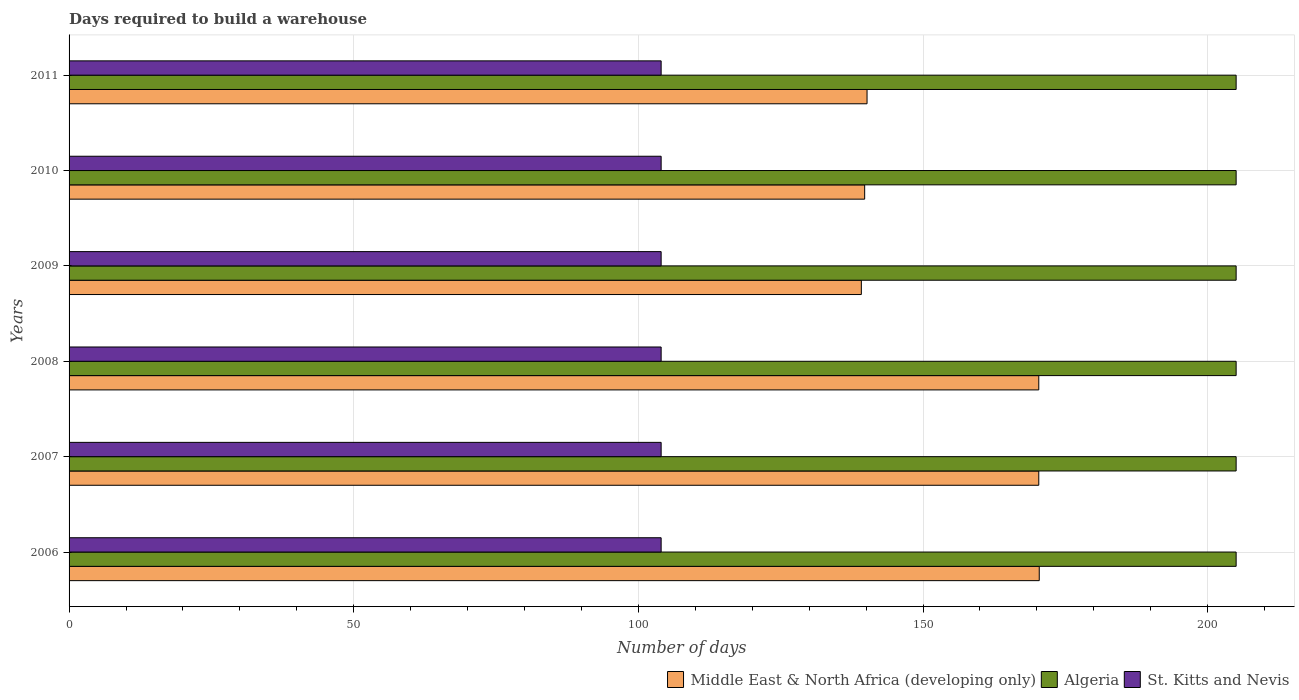How many different coloured bars are there?
Provide a succinct answer. 3. Are the number of bars per tick equal to the number of legend labels?
Give a very brief answer. Yes. Are the number of bars on each tick of the Y-axis equal?
Ensure brevity in your answer.  Yes. How many bars are there on the 5th tick from the bottom?
Your answer should be very brief. 3. What is the days required to build a warehouse in in St. Kitts and Nevis in 2008?
Keep it short and to the point. 104. Across all years, what is the maximum days required to build a warehouse in in Algeria?
Provide a short and direct response. 205. Across all years, what is the minimum days required to build a warehouse in in Middle East & North Africa (developing only)?
Ensure brevity in your answer.  139.17. In which year was the days required to build a warehouse in in St. Kitts and Nevis maximum?
Your answer should be very brief. 2006. In which year was the days required to build a warehouse in in Middle East & North Africa (developing only) minimum?
Provide a short and direct response. 2009. What is the total days required to build a warehouse in in St. Kitts and Nevis in the graph?
Provide a succinct answer. 624. What is the difference between the days required to build a warehouse in in St. Kitts and Nevis in 2006 and that in 2009?
Make the answer very short. 0. What is the difference between the days required to build a warehouse in in Algeria in 2010 and the days required to build a warehouse in in Middle East & North Africa (developing only) in 2011?
Your answer should be compact. 64.83. What is the average days required to build a warehouse in in Middle East & North Africa (developing only) per year?
Give a very brief answer. 155.03. In the year 2011, what is the difference between the days required to build a warehouse in in St. Kitts and Nevis and days required to build a warehouse in in Algeria?
Your answer should be very brief. -101. What is the ratio of the days required to build a warehouse in in Middle East & North Africa (developing only) in 2010 to that in 2011?
Your answer should be very brief. 1. What is the difference between the highest and the second highest days required to build a warehouse in in Middle East & North Africa (developing only)?
Keep it short and to the point. 0.08. What is the difference between the highest and the lowest days required to build a warehouse in in Algeria?
Keep it short and to the point. 0. In how many years, is the days required to build a warehouse in in Middle East & North Africa (developing only) greater than the average days required to build a warehouse in in Middle East & North Africa (developing only) taken over all years?
Your answer should be compact. 3. Is the sum of the days required to build a warehouse in in St. Kitts and Nevis in 2006 and 2007 greater than the maximum days required to build a warehouse in in Algeria across all years?
Your answer should be compact. Yes. What does the 1st bar from the top in 2006 represents?
Make the answer very short. St. Kitts and Nevis. What does the 1st bar from the bottom in 2007 represents?
Provide a short and direct response. Middle East & North Africa (developing only). Are all the bars in the graph horizontal?
Offer a terse response. Yes. What is the difference between two consecutive major ticks on the X-axis?
Provide a short and direct response. 50. Are the values on the major ticks of X-axis written in scientific E-notation?
Your answer should be compact. No. Does the graph contain grids?
Provide a succinct answer. Yes. How are the legend labels stacked?
Ensure brevity in your answer.  Horizontal. What is the title of the graph?
Your answer should be compact. Days required to build a warehouse. What is the label or title of the X-axis?
Your answer should be compact. Number of days. What is the label or title of the Y-axis?
Provide a succinct answer. Years. What is the Number of days of Middle East & North Africa (developing only) in 2006?
Offer a very short reply. 170.42. What is the Number of days of Algeria in 2006?
Provide a succinct answer. 205. What is the Number of days in St. Kitts and Nevis in 2006?
Ensure brevity in your answer.  104. What is the Number of days of Middle East & North Africa (developing only) in 2007?
Ensure brevity in your answer.  170.33. What is the Number of days of Algeria in 2007?
Make the answer very short. 205. What is the Number of days of St. Kitts and Nevis in 2007?
Your answer should be compact. 104. What is the Number of days of Middle East & North Africa (developing only) in 2008?
Ensure brevity in your answer.  170.33. What is the Number of days in Algeria in 2008?
Your response must be concise. 205. What is the Number of days in St. Kitts and Nevis in 2008?
Provide a succinct answer. 104. What is the Number of days in Middle East & North Africa (developing only) in 2009?
Offer a very short reply. 139.17. What is the Number of days in Algeria in 2009?
Keep it short and to the point. 205. What is the Number of days in St. Kitts and Nevis in 2009?
Ensure brevity in your answer.  104. What is the Number of days of Middle East & North Africa (developing only) in 2010?
Keep it short and to the point. 139.75. What is the Number of days in Algeria in 2010?
Offer a very short reply. 205. What is the Number of days of St. Kitts and Nevis in 2010?
Ensure brevity in your answer.  104. What is the Number of days in Middle East & North Africa (developing only) in 2011?
Offer a terse response. 140.17. What is the Number of days in Algeria in 2011?
Give a very brief answer. 205. What is the Number of days of St. Kitts and Nevis in 2011?
Give a very brief answer. 104. Across all years, what is the maximum Number of days in Middle East & North Africa (developing only)?
Offer a very short reply. 170.42. Across all years, what is the maximum Number of days in Algeria?
Make the answer very short. 205. Across all years, what is the maximum Number of days of St. Kitts and Nevis?
Keep it short and to the point. 104. Across all years, what is the minimum Number of days of Middle East & North Africa (developing only)?
Keep it short and to the point. 139.17. Across all years, what is the minimum Number of days of Algeria?
Offer a very short reply. 205. Across all years, what is the minimum Number of days of St. Kitts and Nevis?
Your response must be concise. 104. What is the total Number of days of Middle East & North Africa (developing only) in the graph?
Your response must be concise. 930.17. What is the total Number of days in Algeria in the graph?
Give a very brief answer. 1230. What is the total Number of days in St. Kitts and Nevis in the graph?
Provide a short and direct response. 624. What is the difference between the Number of days in Middle East & North Africa (developing only) in 2006 and that in 2007?
Keep it short and to the point. 0.08. What is the difference between the Number of days of Middle East & North Africa (developing only) in 2006 and that in 2008?
Your answer should be very brief. 0.08. What is the difference between the Number of days in Algeria in 2006 and that in 2008?
Ensure brevity in your answer.  0. What is the difference between the Number of days in Middle East & North Africa (developing only) in 2006 and that in 2009?
Provide a succinct answer. 31.25. What is the difference between the Number of days in Algeria in 2006 and that in 2009?
Offer a very short reply. 0. What is the difference between the Number of days of Middle East & North Africa (developing only) in 2006 and that in 2010?
Keep it short and to the point. 30.67. What is the difference between the Number of days of Middle East & North Africa (developing only) in 2006 and that in 2011?
Provide a succinct answer. 30.25. What is the difference between the Number of days in Algeria in 2006 and that in 2011?
Provide a short and direct response. 0. What is the difference between the Number of days in Middle East & North Africa (developing only) in 2007 and that in 2008?
Give a very brief answer. 0. What is the difference between the Number of days of Algeria in 2007 and that in 2008?
Offer a terse response. 0. What is the difference between the Number of days in Middle East & North Africa (developing only) in 2007 and that in 2009?
Offer a terse response. 31.17. What is the difference between the Number of days of Algeria in 2007 and that in 2009?
Your answer should be compact. 0. What is the difference between the Number of days of St. Kitts and Nevis in 2007 and that in 2009?
Offer a very short reply. 0. What is the difference between the Number of days in Middle East & North Africa (developing only) in 2007 and that in 2010?
Ensure brevity in your answer.  30.58. What is the difference between the Number of days of Algeria in 2007 and that in 2010?
Give a very brief answer. 0. What is the difference between the Number of days of St. Kitts and Nevis in 2007 and that in 2010?
Provide a succinct answer. 0. What is the difference between the Number of days in Middle East & North Africa (developing only) in 2007 and that in 2011?
Your response must be concise. 30.17. What is the difference between the Number of days in Algeria in 2007 and that in 2011?
Ensure brevity in your answer.  0. What is the difference between the Number of days of St. Kitts and Nevis in 2007 and that in 2011?
Keep it short and to the point. 0. What is the difference between the Number of days in Middle East & North Africa (developing only) in 2008 and that in 2009?
Your answer should be very brief. 31.17. What is the difference between the Number of days in Middle East & North Africa (developing only) in 2008 and that in 2010?
Offer a very short reply. 30.58. What is the difference between the Number of days in St. Kitts and Nevis in 2008 and that in 2010?
Offer a terse response. 0. What is the difference between the Number of days in Middle East & North Africa (developing only) in 2008 and that in 2011?
Make the answer very short. 30.17. What is the difference between the Number of days of Middle East & North Africa (developing only) in 2009 and that in 2010?
Your answer should be very brief. -0.58. What is the difference between the Number of days in Middle East & North Africa (developing only) in 2009 and that in 2011?
Provide a short and direct response. -1. What is the difference between the Number of days of St. Kitts and Nevis in 2009 and that in 2011?
Ensure brevity in your answer.  0. What is the difference between the Number of days of Middle East & North Africa (developing only) in 2010 and that in 2011?
Your response must be concise. -0.42. What is the difference between the Number of days of Algeria in 2010 and that in 2011?
Offer a very short reply. 0. What is the difference between the Number of days in Middle East & North Africa (developing only) in 2006 and the Number of days in Algeria in 2007?
Give a very brief answer. -34.58. What is the difference between the Number of days in Middle East & North Africa (developing only) in 2006 and the Number of days in St. Kitts and Nevis in 2007?
Offer a very short reply. 66.42. What is the difference between the Number of days of Algeria in 2006 and the Number of days of St. Kitts and Nevis in 2007?
Provide a succinct answer. 101. What is the difference between the Number of days of Middle East & North Africa (developing only) in 2006 and the Number of days of Algeria in 2008?
Your answer should be compact. -34.58. What is the difference between the Number of days in Middle East & North Africa (developing only) in 2006 and the Number of days in St. Kitts and Nevis in 2008?
Offer a terse response. 66.42. What is the difference between the Number of days in Algeria in 2006 and the Number of days in St. Kitts and Nevis in 2008?
Ensure brevity in your answer.  101. What is the difference between the Number of days of Middle East & North Africa (developing only) in 2006 and the Number of days of Algeria in 2009?
Offer a terse response. -34.58. What is the difference between the Number of days of Middle East & North Africa (developing only) in 2006 and the Number of days of St. Kitts and Nevis in 2009?
Provide a short and direct response. 66.42. What is the difference between the Number of days of Algeria in 2006 and the Number of days of St. Kitts and Nevis in 2009?
Give a very brief answer. 101. What is the difference between the Number of days in Middle East & North Africa (developing only) in 2006 and the Number of days in Algeria in 2010?
Keep it short and to the point. -34.58. What is the difference between the Number of days of Middle East & North Africa (developing only) in 2006 and the Number of days of St. Kitts and Nevis in 2010?
Offer a terse response. 66.42. What is the difference between the Number of days in Algeria in 2006 and the Number of days in St. Kitts and Nevis in 2010?
Your answer should be very brief. 101. What is the difference between the Number of days of Middle East & North Africa (developing only) in 2006 and the Number of days of Algeria in 2011?
Make the answer very short. -34.58. What is the difference between the Number of days of Middle East & North Africa (developing only) in 2006 and the Number of days of St. Kitts and Nevis in 2011?
Your answer should be compact. 66.42. What is the difference between the Number of days in Algeria in 2006 and the Number of days in St. Kitts and Nevis in 2011?
Provide a short and direct response. 101. What is the difference between the Number of days in Middle East & North Africa (developing only) in 2007 and the Number of days in Algeria in 2008?
Your response must be concise. -34.67. What is the difference between the Number of days of Middle East & North Africa (developing only) in 2007 and the Number of days of St. Kitts and Nevis in 2008?
Keep it short and to the point. 66.33. What is the difference between the Number of days of Algeria in 2007 and the Number of days of St. Kitts and Nevis in 2008?
Your response must be concise. 101. What is the difference between the Number of days in Middle East & North Africa (developing only) in 2007 and the Number of days in Algeria in 2009?
Your response must be concise. -34.67. What is the difference between the Number of days of Middle East & North Africa (developing only) in 2007 and the Number of days of St. Kitts and Nevis in 2009?
Your answer should be very brief. 66.33. What is the difference between the Number of days of Algeria in 2007 and the Number of days of St. Kitts and Nevis in 2009?
Provide a succinct answer. 101. What is the difference between the Number of days in Middle East & North Africa (developing only) in 2007 and the Number of days in Algeria in 2010?
Provide a succinct answer. -34.67. What is the difference between the Number of days in Middle East & North Africa (developing only) in 2007 and the Number of days in St. Kitts and Nevis in 2010?
Offer a very short reply. 66.33. What is the difference between the Number of days of Algeria in 2007 and the Number of days of St. Kitts and Nevis in 2010?
Your response must be concise. 101. What is the difference between the Number of days of Middle East & North Africa (developing only) in 2007 and the Number of days of Algeria in 2011?
Offer a terse response. -34.67. What is the difference between the Number of days in Middle East & North Africa (developing only) in 2007 and the Number of days in St. Kitts and Nevis in 2011?
Ensure brevity in your answer.  66.33. What is the difference between the Number of days in Algeria in 2007 and the Number of days in St. Kitts and Nevis in 2011?
Ensure brevity in your answer.  101. What is the difference between the Number of days in Middle East & North Africa (developing only) in 2008 and the Number of days in Algeria in 2009?
Offer a terse response. -34.67. What is the difference between the Number of days of Middle East & North Africa (developing only) in 2008 and the Number of days of St. Kitts and Nevis in 2009?
Provide a succinct answer. 66.33. What is the difference between the Number of days in Algeria in 2008 and the Number of days in St. Kitts and Nevis in 2009?
Offer a terse response. 101. What is the difference between the Number of days in Middle East & North Africa (developing only) in 2008 and the Number of days in Algeria in 2010?
Provide a short and direct response. -34.67. What is the difference between the Number of days of Middle East & North Africa (developing only) in 2008 and the Number of days of St. Kitts and Nevis in 2010?
Offer a terse response. 66.33. What is the difference between the Number of days in Algeria in 2008 and the Number of days in St. Kitts and Nevis in 2010?
Offer a terse response. 101. What is the difference between the Number of days of Middle East & North Africa (developing only) in 2008 and the Number of days of Algeria in 2011?
Provide a short and direct response. -34.67. What is the difference between the Number of days of Middle East & North Africa (developing only) in 2008 and the Number of days of St. Kitts and Nevis in 2011?
Make the answer very short. 66.33. What is the difference between the Number of days of Algeria in 2008 and the Number of days of St. Kitts and Nevis in 2011?
Your response must be concise. 101. What is the difference between the Number of days of Middle East & North Africa (developing only) in 2009 and the Number of days of Algeria in 2010?
Your response must be concise. -65.83. What is the difference between the Number of days of Middle East & North Africa (developing only) in 2009 and the Number of days of St. Kitts and Nevis in 2010?
Offer a very short reply. 35.17. What is the difference between the Number of days in Algeria in 2009 and the Number of days in St. Kitts and Nevis in 2010?
Offer a terse response. 101. What is the difference between the Number of days in Middle East & North Africa (developing only) in 2009 and the Number of days in Algeria in 2011?
Your answer should be compact. -65.83. What is the difference between the Number of days in Middle East & North Africa (developing only) in 2009 and the Number of days in St. Kitts and Nevis in 2011?
Your response must be concise. 35.17. What is the difference between the Number of days in Algeria in 2009 and the Number of days in St. Kitts and Nevis in 2011?
Offer a very short reply. 101. What is the difference between the Number of days in Middle East & North Africa (developing only) in 2010 and the Number of days in Algeria in 2011?
Provide a succinct answer. -65.25. What is the difference between the Number of days in Middle East & North Africa (developing only) in 2010 and the Number of days in St. Kitts and Nevis in 2011?
Provide a short and direct response. 35.75. What is the difference between the Number of days in Algeria in 2010 and the Number of days in St. Kitts and Nevis in 2011?
Your answer should be compact. 101. What is the average Number of days in Middle East & North Africa (developing only) per year?
Keep it short and to the point. 155.03. What is the average Number of days of Algeria per year?
Make the answer very short. 205. What is the average Number of days of St. Kitts and Nevis per year?
Your response must be concise. 104. In the year 2006, what is the difference between the Number of days of Middle East & North Africa (developing only) and Number of days of Algeria?
Offer a terse response. -34.58. In the year 2006, what is the difference between the Number of days in Middle East & North Africa (developing only) and Number of days in St. Kitts and Nevis?
Your answer should be compact. 66.42. In the year 2006, what is the difference between the Number of days in Algeria and Number of days in St. Kitts and Nevis?
Offer a very short reply. 101. In the year 2007, what is the difference between the Number of days of Middle East & North Africa (developing only) and Number of days of Algeria?
Offer a very short reply. -34.67. In the year 2007, what is the difference between the Number of days of Middle East & North Africa (developing only) and Number of days of St. Kitts and Nevis?
Provide a succinct answer. 66.33. In the year 2007, what is the difference between the Number of days in Algeria and Number of days in St. Kitts and Nevis?
Keep it short and to the point. 101. In the year 2008, what is the difference between the Number of days in Middle East & North Africa (developing only) and Number of days in Algeria?
Your answer should be compact. -34.67. In the year 2008, what is the difference between the Number of days of Middle East & North Africa (developing only) and Number of days of St. Kitts and Nevis?
Offer a very short reply. 66.33. In the year 2008, what is the difference between the Number of days of Algeria and Number of days of St. Kitts and Nevis?
Ensure brevity in your answer.  101. In the year 2009, what is the difference between the Number of days in Middle East & North Africa (developing only) and Number of days in Algeria?
Ensure brevity in your answer.  -65.83. In the year 2009, what is the difference between the Number of days of Middle East & North Africa (developing only) and Number of days of St. Kitts and Nevis?
Ensure brevity in your answer.  35.17. In the year 2009, what is the difference between the Number of days in Algeria and Number of days in St. Kitts and Nevis?
Your response must be concise. 101. In the year 2010, what is the difference between the Number of days of Middle East & North Africa (developing only) and Number of days of Algeria?
Your answer should be very brief. -65.25. In the year 2010, what is the difference between the Number of days of Middle East & North Africa (developing only) and Number of days of St. Kitts and Nevis?
Provide a succinct answer. 35.75. In the year 2010, what is the difference between the Number of days of Algeria and Number of days of St. Kitts and Nevis?
Your answer should be compact. 101. In the year 2011, what is the difference between the Number of days of Middle East & North Africa (developing only) and Number of days of Algeria?
Ensure brevity in your answer.  -64.83. In the year 2011, what is the difference between the Number of days in Middle East & North Africa (developing only) and Number of days in St. Kitts and Nevis?
Offer a very short reply. 36.17. In the year 2011, what is the difference between the Number of days in Algeria and Number of days in St. Kitts and Nevis?
Keep it short and to the point. 101. What is the ratio of the Number of days of Algeria in 2006 to that in 2008?
Provide a short and direct response. 1. What is the ratio of the Number of days of Middle East & North Africa (developing only) in 2006 to that in 2009?
Offer a very short reply. 1.22. What is the ratio of the Number of days in St. Kitts and Nevis in 2006 to that in 2009?
Provide a succinct answer. 1. What is the ratio of the Number of days in Middle East & North Africa (developing only) in 2006 to that in 2010?
Provide a short and direct response. 1.22. What is the ratio of the Number of days in Algeria in 2006 to that in 2010?
Your answer should be very brief. 1. What is the ratio of the Number of days in St. Kitts and Nevis in 2006 to that in 2010?
Provide a succinct answer. 1. What is the ratio of the Number of days of Middle East & North Africa (developing only) in 2006 to that in 2011?
Your response must be concise. 1.22. What is the ratio of the Number of days of St. Kitts and Nevis in 2006 to that in 2011?
Ensure brevity in your answer.  1. What is the ratio of the Number of days of Algeria in 2007 to that in 2008?
Your answer should be compact. 1. What is the ratio of the Number of days in St. Kitts and Nevis in 2007 to that in 2008?
Keep it short and to the point. 1. What is the ratio of the Number of days of Middle East & North Africa (developing only) in 2007 to that in 2009?
Offer a terse response. 1.22. What is the ratio of the Number of days in Algeria in 2007 to that in 2009?
Your answer should be compact. 1. What is the ratio of the Number of days in St. Kitts and Nevis in 2007 to that in 2009?
Make the answer very short. 1. What is the ratio of the Number of days of Middle East & North Africa (developing only) in 2007 to that in 2010?
Offer a very short reply. 1.22. What is the ratio of the Number of days in Algeria in 2007 to that in 2010?
Provide a short and direct response. 1. What is the ratio of the Number of days in Middle East & North Africa (developing only) in 2007 to that in 2011?
Offer a terse response. 1.22. What is the ratio of the Number of days of Middle East & North Africa (developing only) in 2008 to that in 2009?
Provide a succinct answer. 1.22. What is the ratio of the Number of days of Algeria in 2008 to that in 2009?
Offer a very short reply. 1. What is the ratio of the Number of days in St. Kitts and Nevis in 2008 to that in 2009?
Provide a succinct answer. 1. What is the ratio of the Number of days of Middle East & North Africa (developing only) in 2008 to that in 2010?
Your response must be concise. 1.22. What is the ratio of the Number of days in St. Kitts and Nevis in 2008 to that in 2010?
Your answer should be very brief. 1. What is the ratio of the Number of days of Middle East & North Africa (developing only) in 2008 to that in 2011?
Offer a very short reply. 1.22. What is the ratio of the Number of days of Algeria in 2008 to that in 2011?
Your answer should be compact. 1. What is the ratio of the Number of days in Middle East & North Africa (developing only) in 2009 to that in 2010?
Provide a short and direct response. 1. What is the ratio of the Number of days in Algeria in 2009 to that in 2011?
Ensure brevity in your answer.  1. What is the ratio of the Number of days in Middle East & North Africa (developing only) in 2010 to that in 2011?
Ensure brevity in your answer.  1. What is the ratio of the Number of days of St. Kitts and Nevis in 2010 to that in 2011?
Give a very brief answer. 1. What is the difference between the highest and the second highest Number of days of Middle East & North Africa (developing only)?
Your answer should be compact. 0.08. What is the difference between the highest and the second highest Number of days in Algeria?
Offer a terse response. 0. What is the difference between the highest and the second highest Number of days in St. Kitts and Nevis?
Give a very brief answer. 0. What is the difference between the highest and the lowest Number of days of Middle East & North Africa (developing only)?
Ensure brevity in your answer.  31.25. What is the difference between the highest and the lowest Number of days in St. Kitts and Nevis?
Ensure brevity in your answer.  0. 